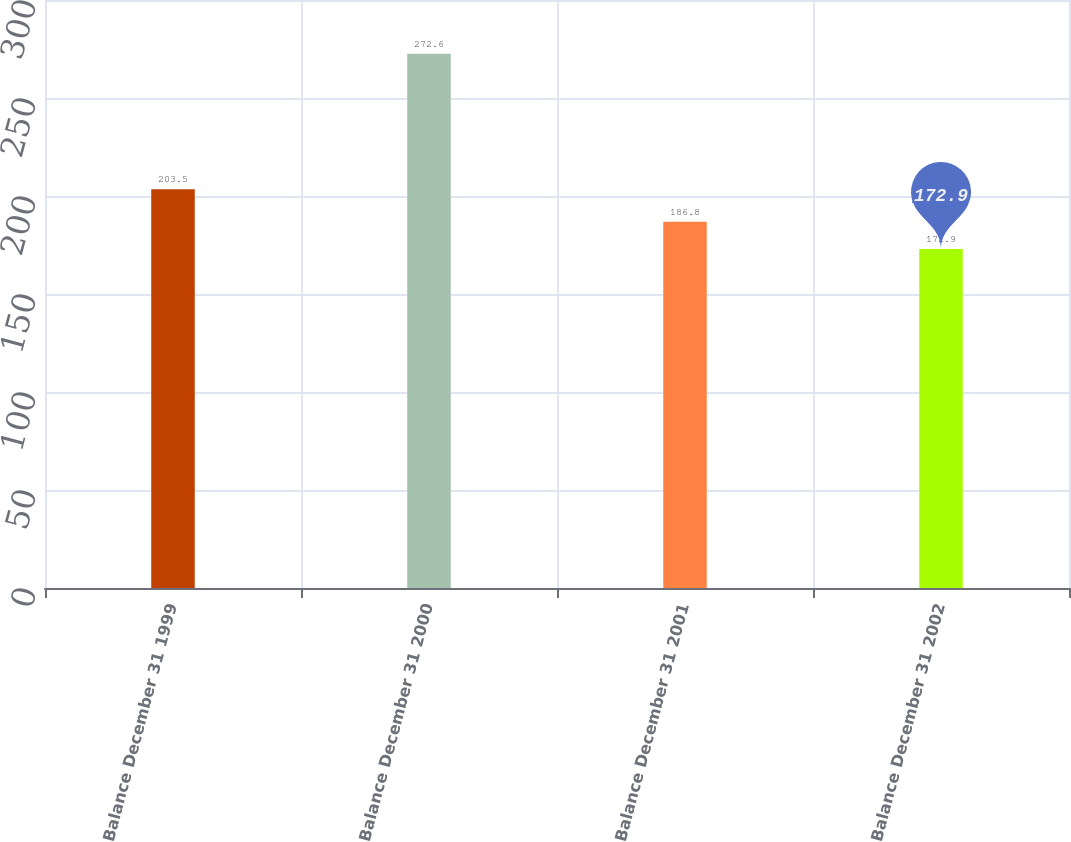<chart> <loc_0><loc_0><loc_500><loc_500><bar_chart><fcel>Balance December 31 1999<fcel>Balance December 31 2000<fcel>Balance December 31 2001<fcel>Balance December 31 2002<nl><fcel>203.5<fcel>272.6<fcel>186.8<fcel>172.9<nl></chart> 